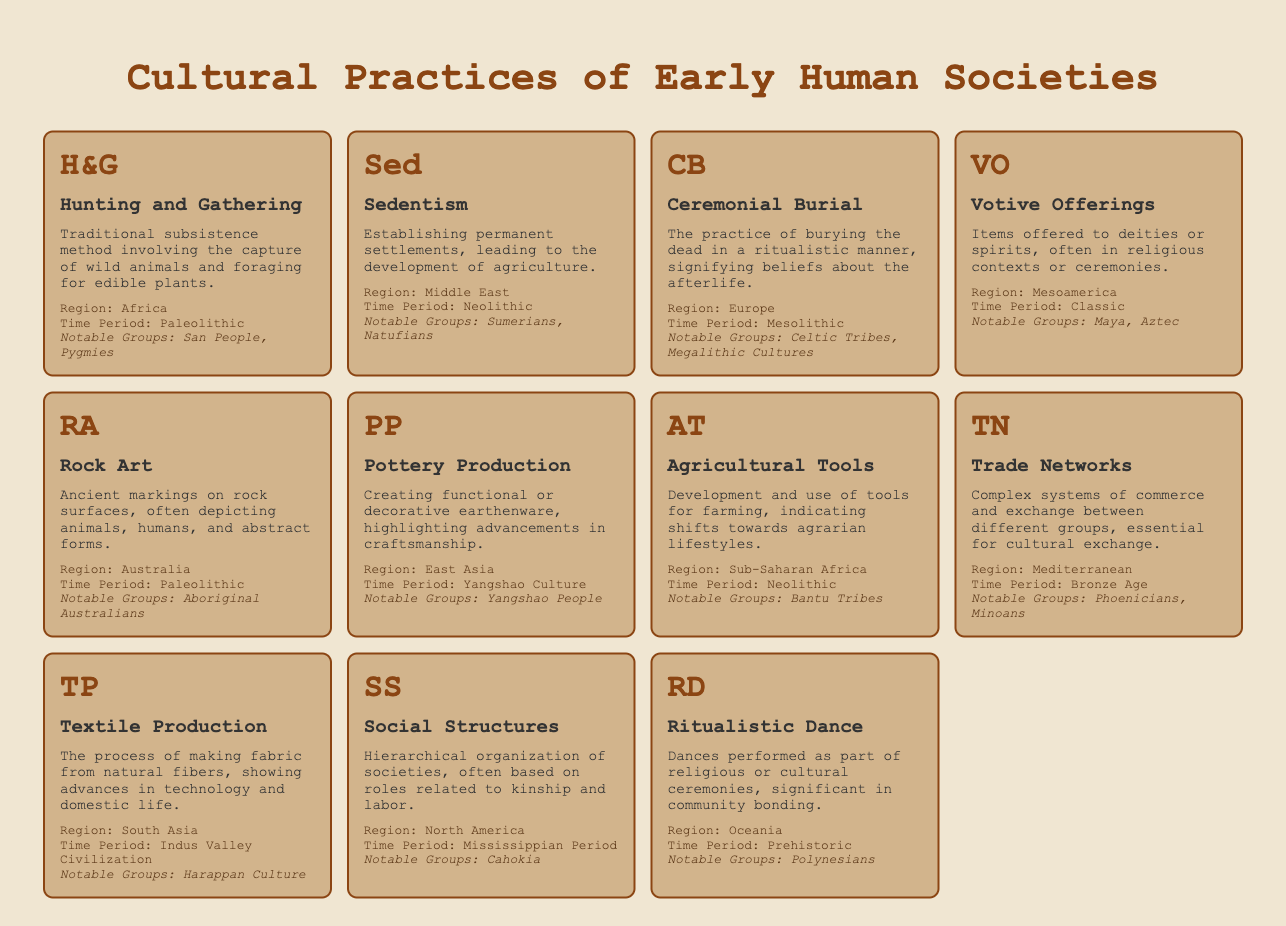What cultural practice is associated with the San People? The San People are associated with the cultural practice of Hunting and Gathering, as it is noted in the table under Africa and the Paleolithic time period.
Answer: Hunting and Gathering Which region is linked to Pottery Production? Pottery Production is linked to East Asia, as indicated in the table.
Answer: East Asia Are Votive Offerings practiced in the Paleolithic time period? No, Votive Offerings are practiced in the Classic time period, specifically in Mesoamerica, as mentioned in the table.
Answer: No What notable groups are associated with the practice of Agricultural Tools? The notable groups associated with Agricultural Tools are the Bantu Tribes, as listed in the table under Sub-Saharan Africa and the Neolithic time period.
Answer: Bantu Tribes How many cultural practices are associated with the Middle East? There is 1 cultural practice associated with the Middle East, namely Sedentism. The table shows that this is the only entry for this region.
Answer: 1 Which cultural practice had the most recent time period mentioned in the table? The cultural practice with the most recent time period is Trade Networks, which falls under the Bronze Age in the Mediterranean region.
Answer: Trade Networks Is it true that Rock Art is associated with North America? No, Rock Art is associated with Australia as stated in the table. Thus, the statement is false.
Answer: No How many cultural practices are linked to the region of Oceania? There is 1 cultural practice linked to Oceania, which is Ritualistic Dance, as noted in the table.
Answer: 1 What is the time period for the Social Structures cultural practice? The time period for Social Structures is the Mississippian Period, as indicated in the table under North America.
Answer: Mississippian Period 